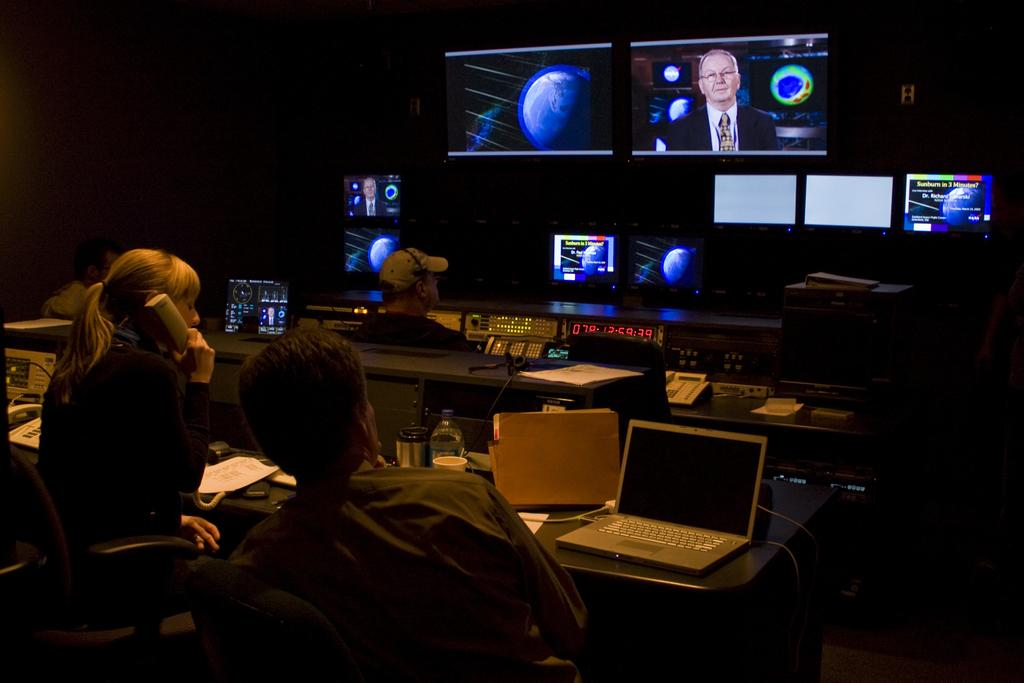<image>
Present a compact description of the photo's key features. In a TV control room, workers watch as a report on sunburn plays out. 